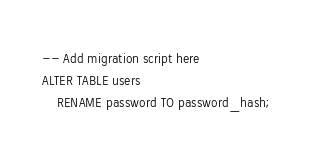<code> <loc_0><loc_0><loc_500><loc_500><_SQL_>-- Add migration script here
ALTER TABLE users
    RENAME password TO password_hash;</code> 